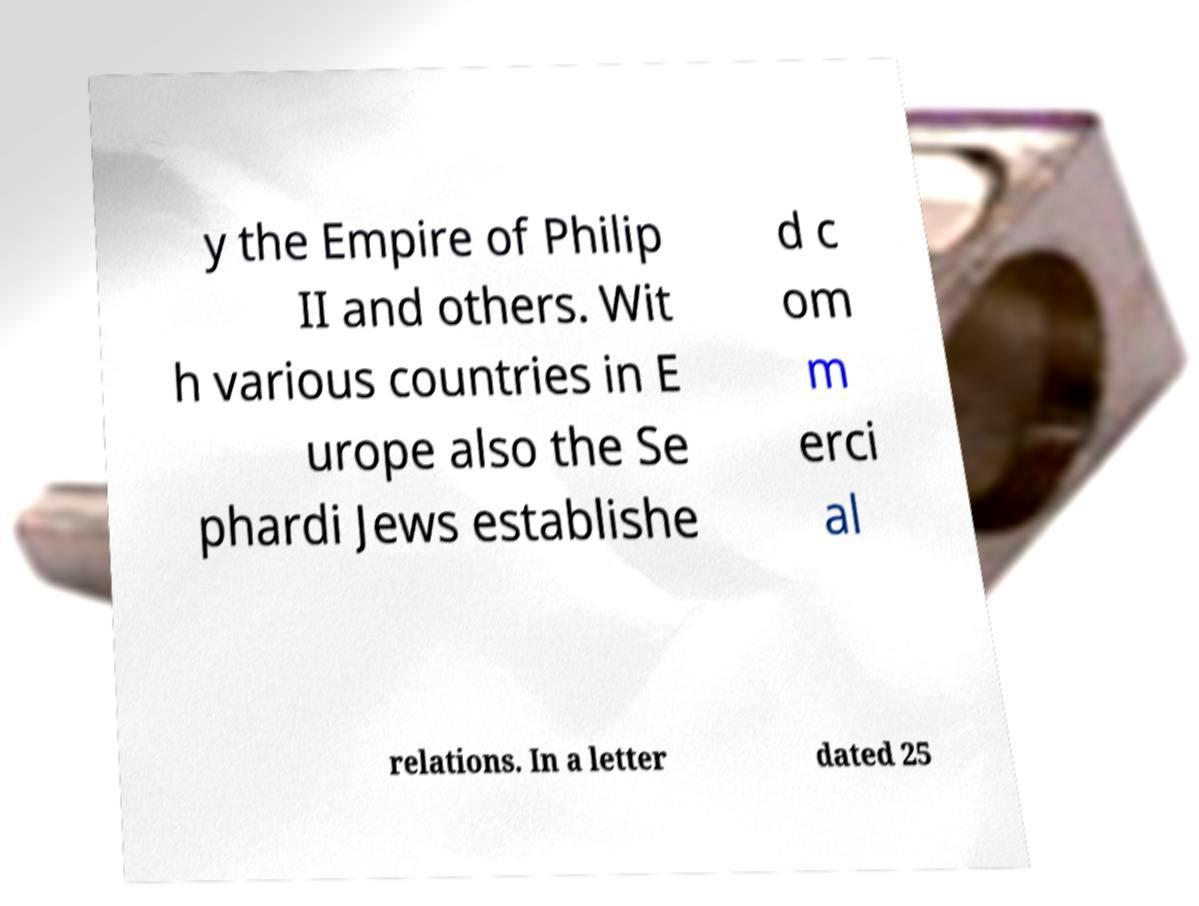What messages or text are displayed in this image? I need them in a readable, typed format. y the Empire of Philip II and others. Wit h various countries in E urope also the Se phardi Jews establishe d c om m erci al relations. In a letter dated 25 